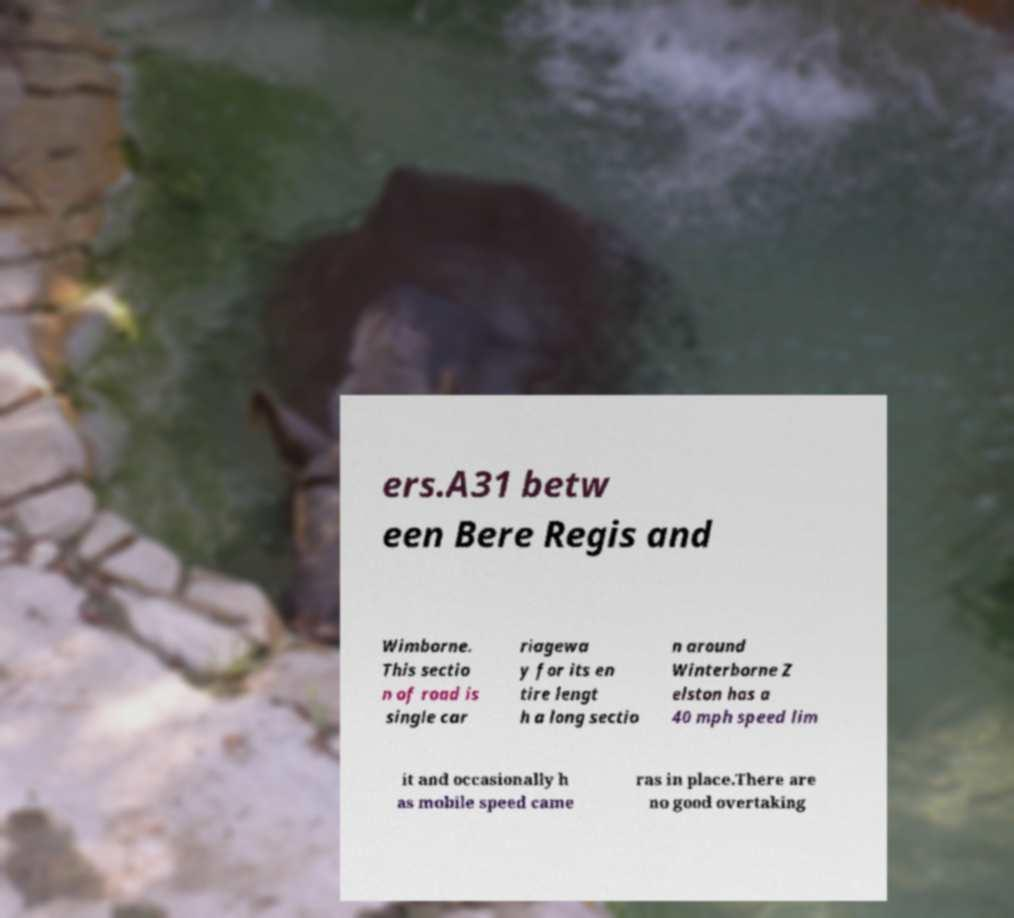For documentation purposes, I need the text within this image transcribed. Could you provide that? ers.A31 betw een Bere Regis and Wimborne. This sectio n of road is single car riagewa y for its en tire lengt h a long sectio n around Winterborne Z elston has a 40 mph speed lim it and occasionally h as mobile speed came ras in place.There are no good overtaking 